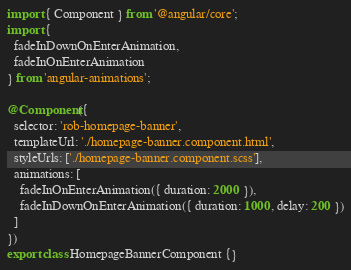<code> <loc_0><loc_0><loc_500><loc_500><_TypeScript_>import { Component } from '@angular/core';
import {
  fadeInDownOnEnterAnimation,
  fadeInOnEnterAnimation
} from 'angular-animations';

@Component({
  selector: 'rob-homepage-banner',
  templateUrl: './homepage-banner.component.html',
  styleUrls: ['./homepage-banner.component.scss'],
  animations: [
    fadeInOnEnterAnimation({ duration: 2000 }),
    fadeInDownOnEnterAnimation({ duration: 1000, delay: 200 })
  ]
})
export class HomepageBannerComponent {}
</code> 